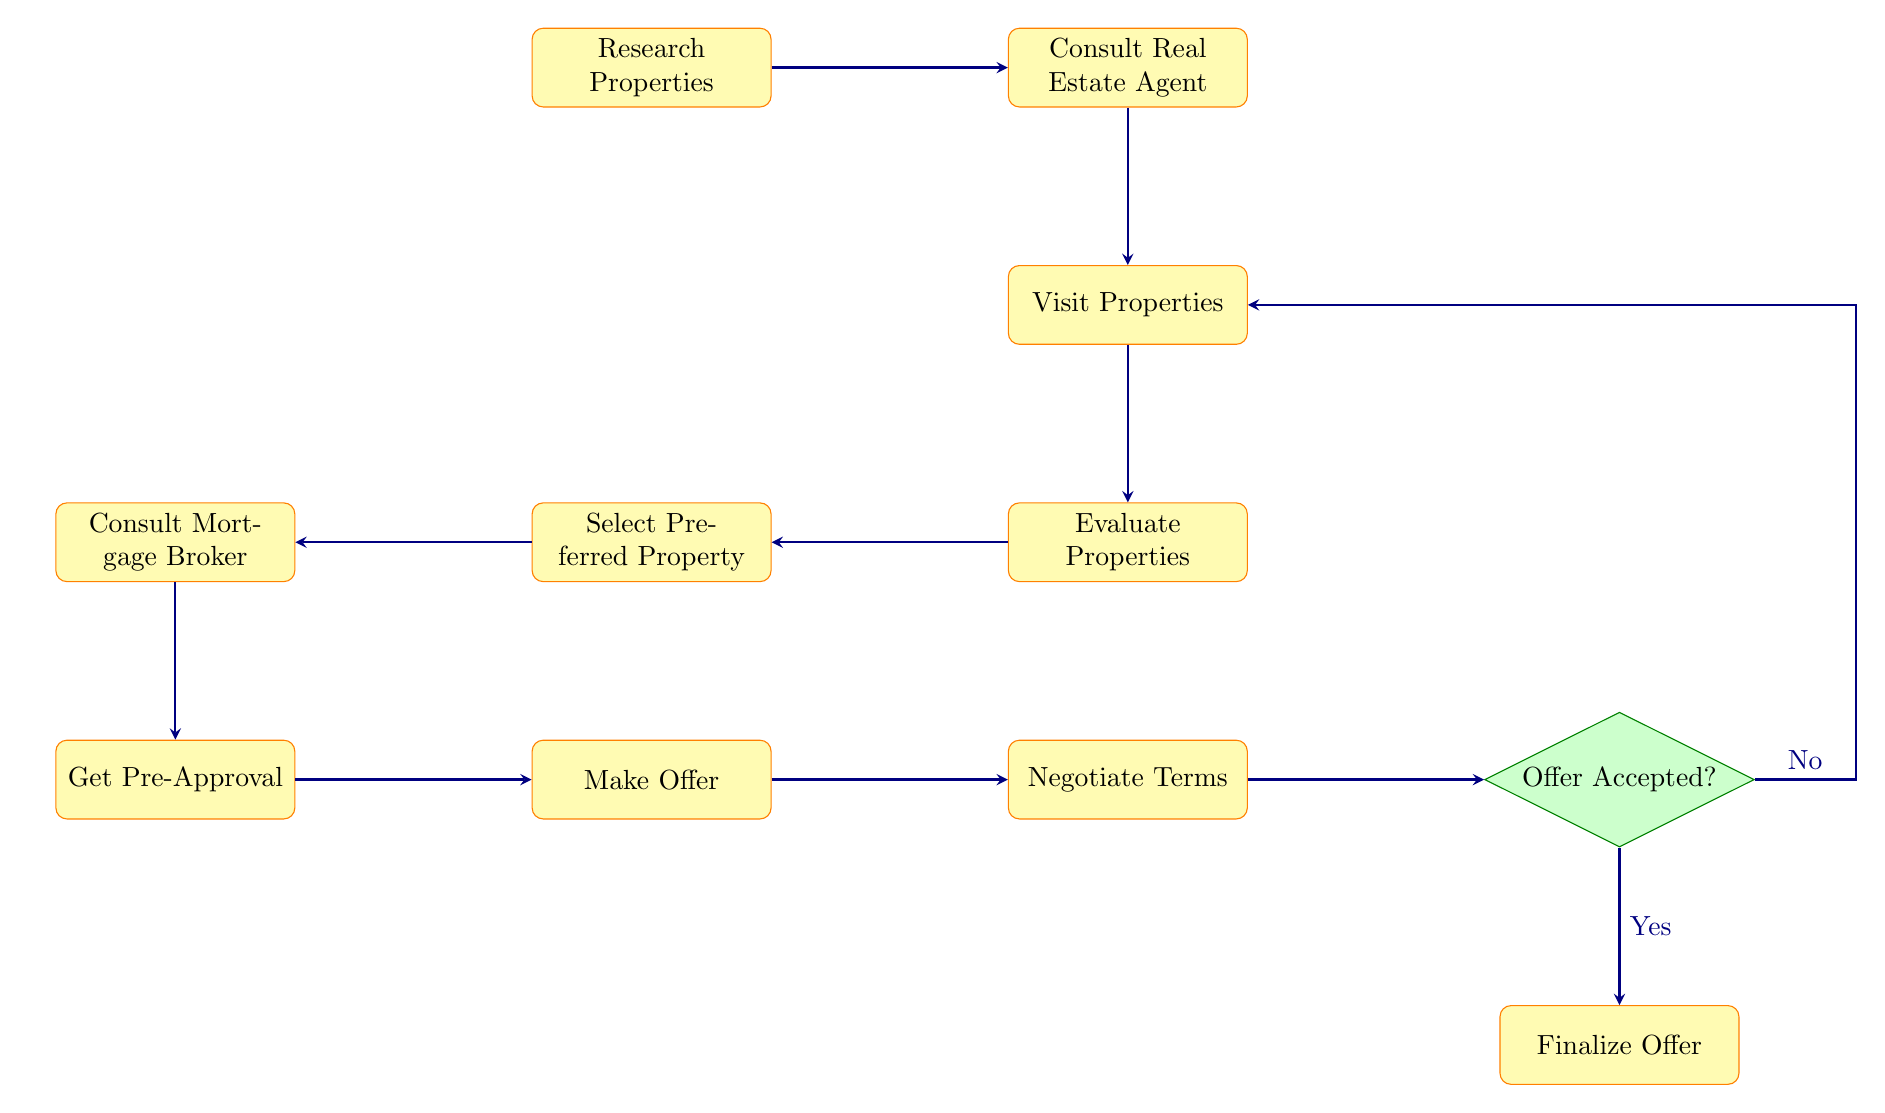What is the first step in the flow chart? The first step is labeled "Research Properties," which is the starting node in the diagram.
Answer: Research Properties How many processes are there in total? To find the total number of processes, count all the nodes categorized as "process" in the diagram. There are 10 such nodes.
Answer: 10 What comes after "Visit Properties"? The node that follows "Visit Properties" is "Evaluate Properties," which is directly below it in the diagram's flow.
Answer: Evaluate Properties What is the decision point in the flow chart? The decision point, located in the right portion of the diagram, is labeled "Offer Accepted?" which determines the next steps based on the seller's response.
Answer: Offer Accepted? If the offer is not accepted, where do you go next? If the offer is not accepted, the direction shown is to return to "Visit Properties," indicating you may need to consider other properties again.
Answer: Visit Properties What must you do before making an offer? Before making an offer, the step is to "Get Pre-Approval," which is completed after consulting the mortgage broker.
Answer: Get Pre-Approval What node leads to "Negotiate Terms"? The node directly leading to "Negotiate Terms" is "Make Offer," as it precedes the negotiation step in the flow.
Answer: Make Offer What happens after the offer is accepted? After the offer is accepted, the flow leads to the step "Finalize Offer," indicating that the next phase involves completing the offer process.
Answer: Finalize Offer What action comes before consulting the mortgage broker? The action that comes before consulting the mortgage broker is "Select Preferred Property," which implies a selection has to be made based on property evaluations.
Answer: Select Preferred Property 